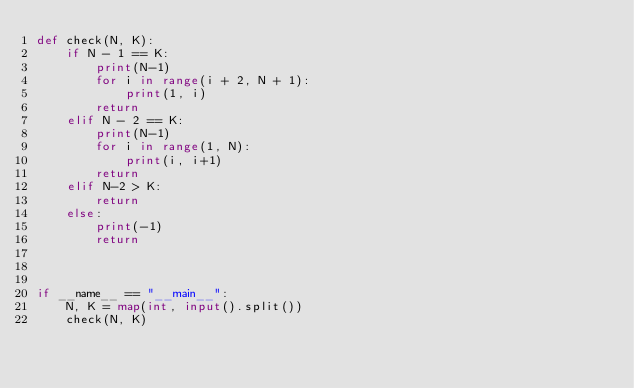<code> <loc_0><loc_0><loc_500><loc_500><_Python_>def check(N, K):
    if N - 1 == K:
        print(N-1)
        for i in range(i + 2, N + 1):
            print(1, i)
        return
    elif N - 2 == K:
        print(N-1)
        for i in range(1, N):
            print(i, i+1)
        return
    elif N-2 > K:
        return
    else:
        print(-1)
        return



if __name__ == "__main__":
    N, K = map(int, input().split())
    check(N, K)
</code> 